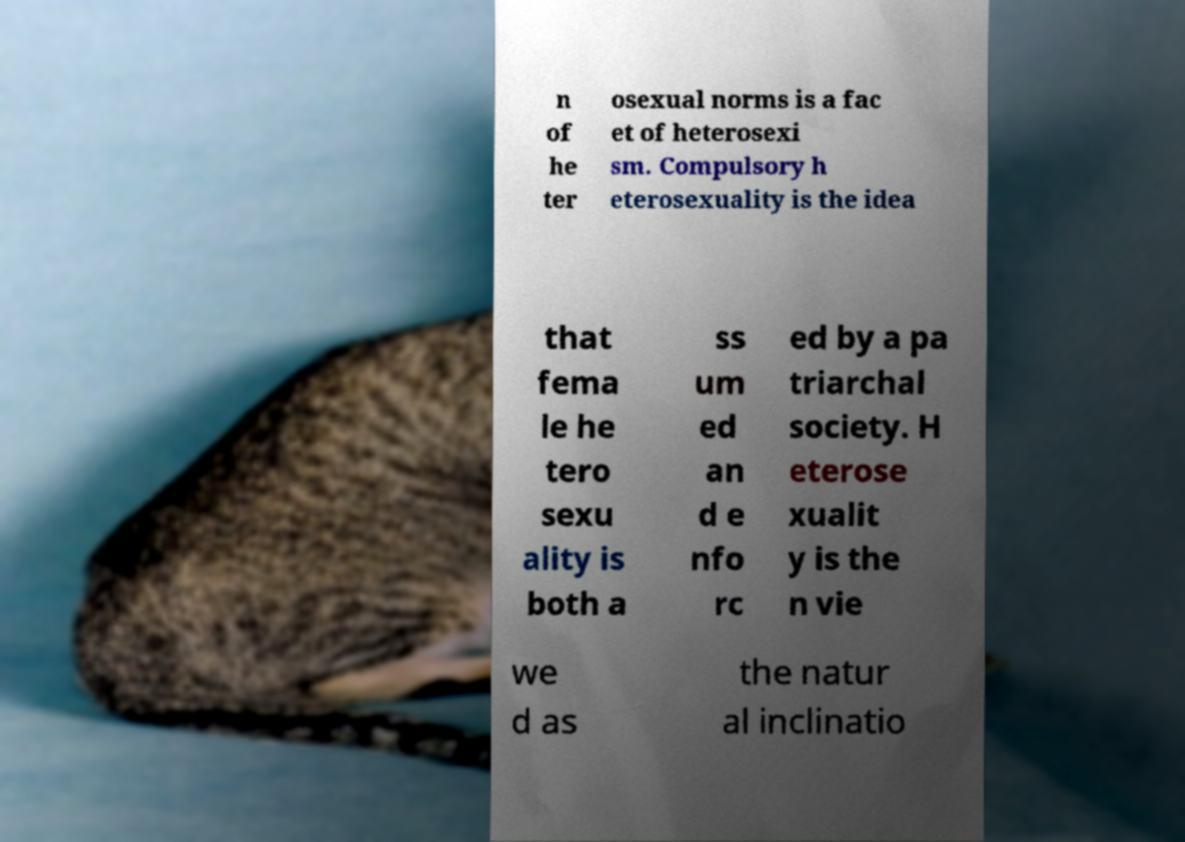Can you accurately transcribe the text from the provided image for me? n of he ter osexual norms is a fac et of heterosexi sm. Compulsory h eterosexuality is the idea that fema le he tero sexu ality is both a ss um ed an d e nfo rc ed by a pa triarchal society. H eterose xualit y is the n vie we d as the natur al inclinatio 